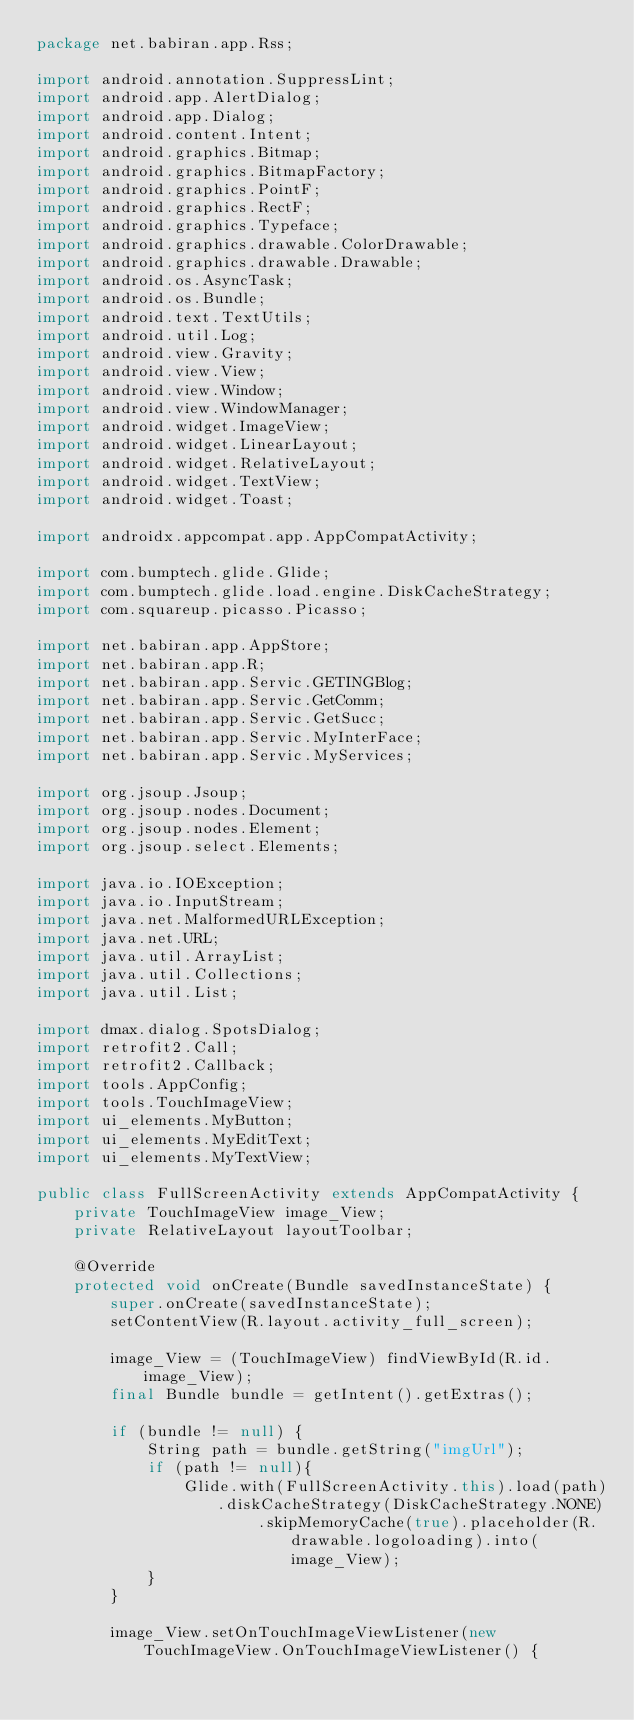<code> <loc_0><loc_0><loc_500><loc_500><_Java_>package net.babiran.app.Rss;

import android.annotation.SuppressLint;
import android.app.AlertDialog;
import android.app.Dialog;
import android.content.Intent;
import android.graphics.Bitmap;
import android.graphics.BitmapFactory;
import android.graphics.PointF;
import android.graphics.RectF;
import android.graphics.Typeface;
import android.graphics.drawable.ColorDrawable;
import android.graphics.drawable.Drawable;
import android.os.AsyncTask;
import android.os.Bundle;
import android.text.TextUtils;
import android.util.Log;
import android.view.Gravity;
import android.view.View;
import android.view.Window;
import android.view.WindowManager;
import android.widget.ImageView;
import android.widget.LinearLayout;
import android.widget.RelativeLayout;
import android.widget.TextView;
import android.widget.Toast;

import androidx.appcompat.app.AppCompatActivity;

import com.bumptech.glide.Glide;
import com.bumptech.glide.load.engine.DiskCacheStrategy;
import com.squareup.picasso.Picasso;

import net.babiran.app.AppStore;
import net.babiran.app.R;
import net.babiran.app.Servic.GETINGBlog;
import net.babiran.app.Servic.GetComm;
import net.babiran.app.Servic.GetSucc;
import net.babiran.app.Servic.MyInterFace;
import net.babiran.app.Servic.MyServices;

import org.jsoup.Jsoup;
import org.jsoup.nodes.Document;
import org.jsoup.nodes.Element;
import org.jsoup.select.Elements;

import java.io.IOException;
import java.io.InputStream;
import java.net.MalformedURLException;
import java.net.URL;
import java.util.ArrayList;
import java.util.Collections;
import java.util.List;

import dmax.dialog.SpotsDialog;
import retrofit2.Call;
import retrofit2.Callback;
import tools.AppConfig;
import tools.TouchImageView;
import ui_elements.MyButton;
import ui_elements.MyEditText;
import ui_elements.MyTextView;

public class FullScreenActivity extends AppCompatActivity {
    private TouchImageView image_View;
    private RelativeLayout layoutToolbar;

    @Override
    protected void onCreate(Bundle savedInstanceState) {
        super.onCreate(savedInstanceState);
        setContentView(R.layout.activity_full_screen);

        image_View = (TouchImageView) findViewById(R.id.image_View);
        final Bundle bundle = getIntent().getExtras();

        if (bundle != null) {
            String path = bundle.getString("imgUrl");
            if (path != null){
                Glide.with(FullScreenActivity.this).load(path).diskCacheStrategy(DiskCacheStrategy.NONE)
                        .skipMemoryCache(true).placeholder(R.drawable.logoloading).into(image_View);
            }
        }

        image_View.setOnTouchImageViewListener(new TouchImageView.OnTouchImageViewListener() {</code> 